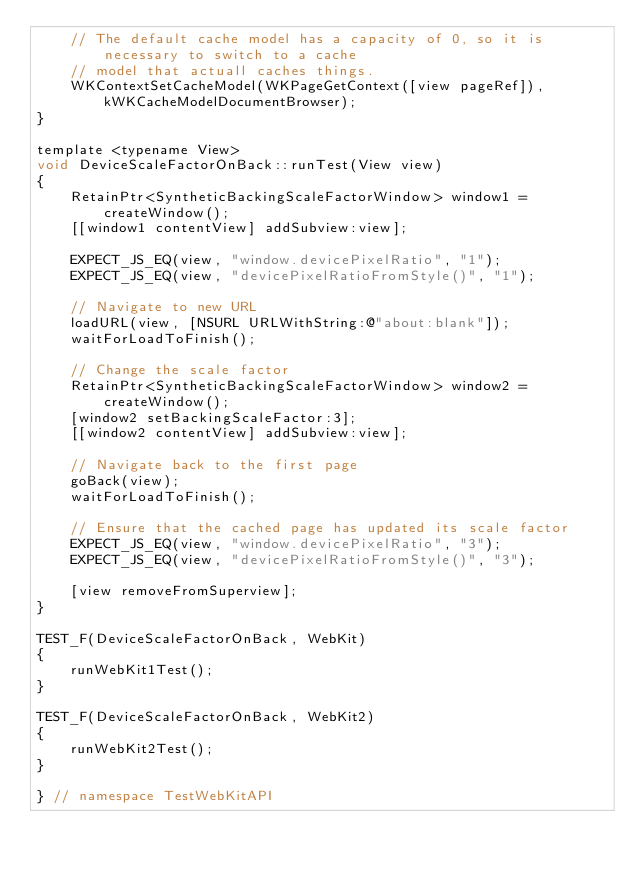Convert code to text. <code><loc_0><loc_0><loc_500><loc_500><_ObjectiveC_>    // The default cache model has a capacity of 0, so it is necessary to switch to a cache
    // model that actuall caches things.
    WKContextSetCacheModel(WKPageGetContext([view pageRef]), kWKCacheModelDocumentBrowser);
}

template <typename View>
void DeviceScaleFactorOnBack::runTest(View view)
{
    RetainPtr<SyntheticBackingScaleFactorWindow> window1 = createWindow();
    [[window1 contentView] addSubview:view];

    EXPECT_JS_EQ(view, "window.devicePixelRatio", "1");
    EXPECT_JS_EQ(view, "devicePixelRatioFromStyle()", "1");

    // Navigate to new URL
    loadURL(view, [NSURL URLWithString:@"about:blank"]);
    waitForLoadToFinish();

    // Change the scale factor
    RetainPtr<SyntheticBackingScaleFactorWindow> window2 = createWindow();
    [window2 setBackingScaleFactor:3];
    [[window2 contentView] addSubview:view];

    // Navigate back to the first page
    goBack(view);
    waitForLoadToFinish();

    // Ensure that the cached page has updated its scale factor
    EXPECT_JS_EQ(view, "window.devicePixelRatio", "3");
    EXPECT_JS_EQ(view, "devicePixelRatioFromStyle()", "3");

    [view removeFromSuperview];
}

TEST_F(DeviceScaleFactorOnBack, WebKit)
{
    runWebKit1Test();
}

TEST_F(DeviceScaleFactorOnBack, WebKit2)
{
    runWebKit2Test();
}

} // namespace TestWebKitAPI
</code> 